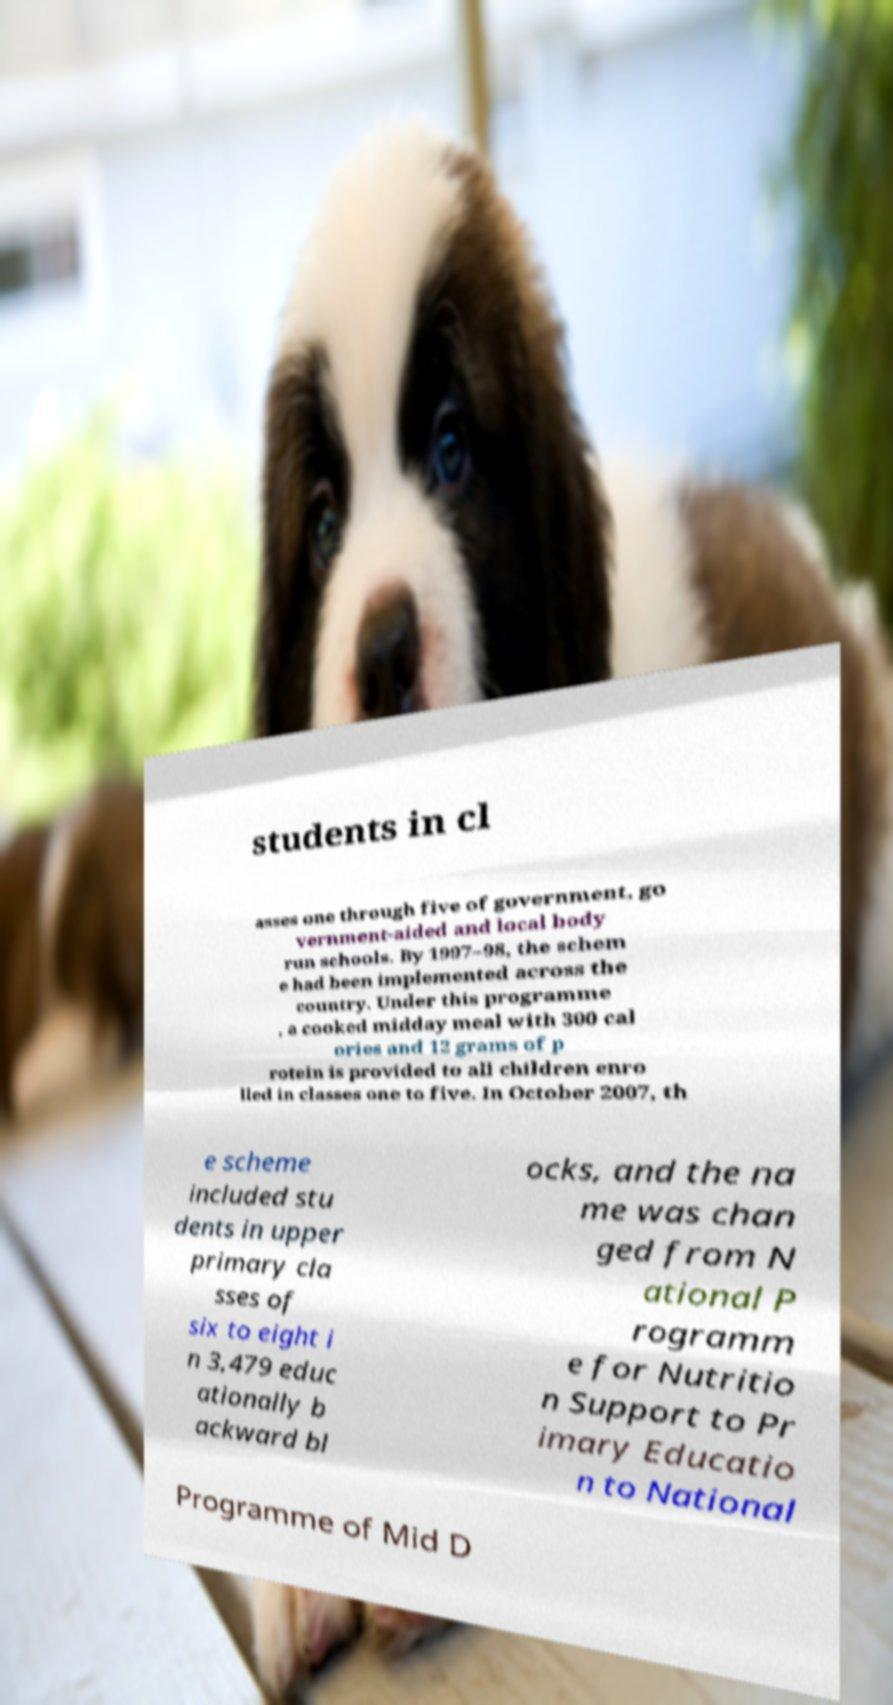Could you extract and type out the text from this image? students in cl asses one through five of government, go vernment-aided and local body run schools. By 1997–98, the schem e had been implemented across the country. Under this programme , a cooked midday meal with 300 cal ories and 12 grams of p rotein is provided to all children enro lled in classes one to five. In October 2007, th e scheme included stu dents in upper primary cla sses of six to eight i n 3,479 educ ationally b ackward bl ocks, and the na me was chan ged from N ational P rogramm e for Nutritio n Support to Pr imary Educatio n to National Programme of Mid D 